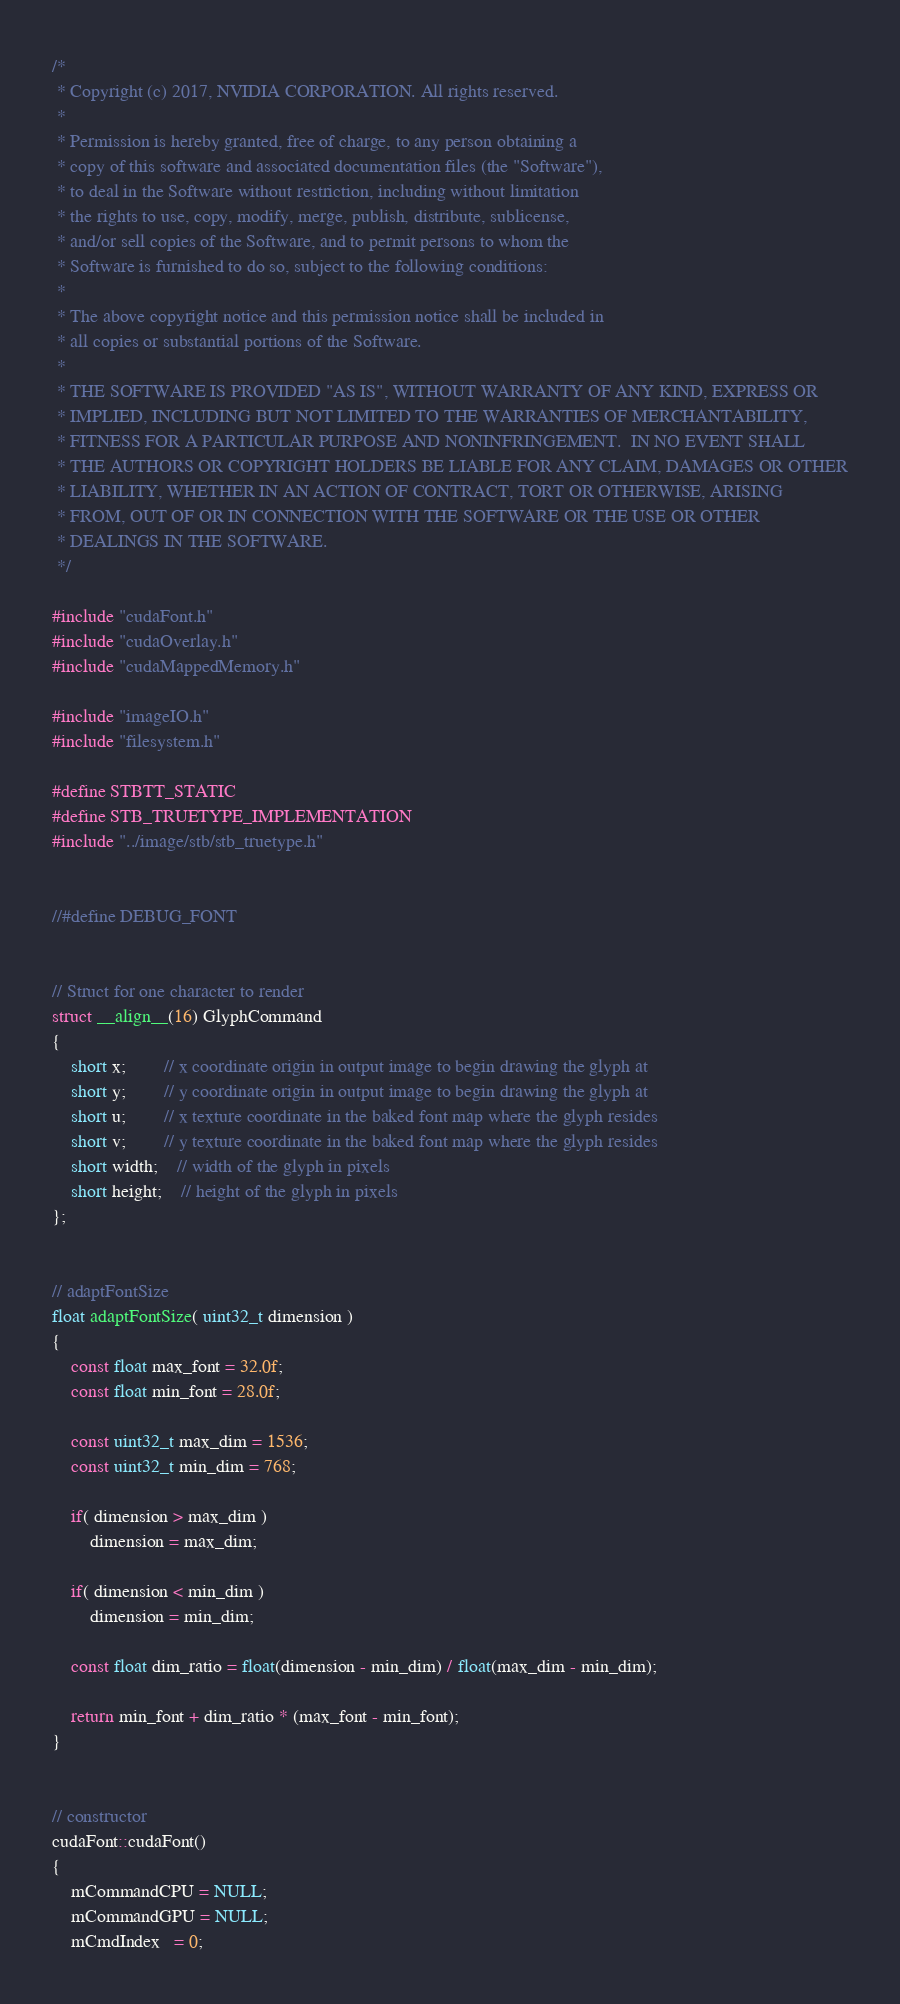Convert code to text. <code><loc_0><loc_0><loc_500><loc_500><_Cuda_>/*
 * Copyright (c) 2017, NVIDIA CORPORATION. All rights reserved.
 *
 * Permission is hereby granted, free of charge, to any person obtaining a
 * copy of this software and associated documentation files (the "Software"),
 * to deal in the Software without restriction, including without limitation
 * the rights to use, copy, modify, merge, publish, distribute, sublicense,
 * and/or sell copies of the Software, and to permit persons to whom the
 * Software is furnished to do so, subject to the following conditions:
 *
 * The above copyright notice and this permission notice shall be included in
 * all copies or substantial portions of the Software.
 *
 * THE SOFTWARE IS PROVIDED "AS IS", WITHOUT WARRANTY OF ANY KIND, EXPRESS OR
 * IMPLIED, INCLUDING BUT NOT LIMITED TO THE WARRANTIES OF MERCHANTABILITY,
 * FITNESS FOR A PARTICULAR PURPOSE AND NONINFRINGEMENT.  IN NO EVENT SHALL
 * THE AUTHORS OR COPYRIGHT HOLDERS BE LIABLE FOR ANY CLAIM, DAMAGES OR OTHER
 * LIABILITY, WHETHER IN AN ACTION OF CONTRACT, TORT OR OTHERWISE, ARISING
 * FROM, OUT OF OR IN CONNECTION WITH THE SOFTWARE OR THE USE OR OTHER
 * DEALINGS IN THE SOFTWARE.
 */

#include "cudaFont.h"
#include "cudaOverlay.h"
#include "cudaMappedMemory.h"

#include "imageIO.h"
#include "filesystem.h"

#define STBTT_STATIC
#define STB_TRUETYPE_IMPLEMENTATION
#include "../image/stb/stb_truetype.h"


//#define DEBUG_FONT


// Struct for one character to render
struct __align__(16) GlyphCommand
{
	short x;		// x coordinate origin in output image to begin drawing the glyph at 
	short y;		// y coordinate origin in output image to begin drawing the glyph at 
	short u;		// x texture coordinate in the baked font map where the glyph resides
	short v;		// y texture coordinate in the baked font map where the glyph resides 
	short width;	// width of the glyph in pixels
	short height;	// height of the glyph in pixels
};


// adaptFontSize
float adaptFontSize( uint32_t dimension )
{
	const float max_font = 32.0f;
	const float min_font = 28.0f;

	const uint32_t max_dim = 1536;
	const uint32_t min_dim = 768;

	if( dimension > max_dim )
		dimension = max_dim;

	if( dimension < min_dim )
		dimension = min_dim;

	const float dim_ratio = float(dimension - min_dim) / float(max_dim - min_dim);

	return min_font + dim_ratio * (max_font - min_font);
}


// constructor
cudaFont::cudaFont()
{
	mCommandCPU = NULL;
	mCommandGPU = NULL;
	mCmdIndex   = 0;
</code> 